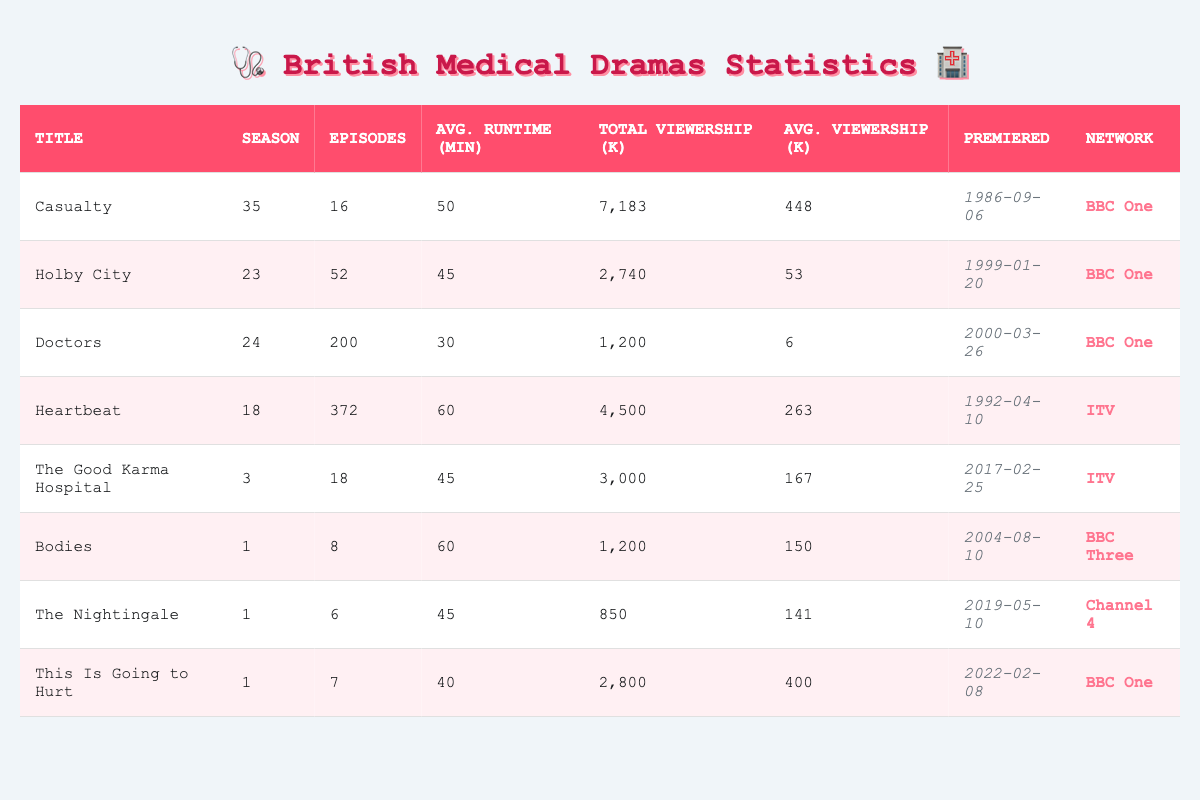What is the average runtime of "Doctors"? The average runtime for "Doctors" as listed in the table is 30 minutes.
Answer: 30 minutes Which show has the highest total viewership? "Casualty" has the highest total viewership with 7,183 thousands (or 7.183 million) viewers.
Answer: Casualty How many seasons does "Heartbeat" have? "Heartbeat" is reported to have 18 seasons.
Answer: 18 seasons What is the average viewership of "The Good Karma Hospital"? The average viewership for "The Good Karma Hospital" is 167 thousands (or 167,000) viewers.
Answer: 167 thousands Which show aired first, "Holby City" or "Doctors"? "Holby City" premiered on January 20, 1999, whereas "Doctors" premiered on March 26, 2000. Therefore, "Holby City" aired first.
Answer: Holby City How many episodes does "Bodies" have compared to "This Is Going to Hurt"? "Bodies" has 8 episodes while "This Is Going to Hurt" has 7 episodes, so "Bodies" has 1 more episode than "This Is Going to Hurt."
Answer: 1 more episode What is the total number of episodes for shows aired on BBC One? The total number of episodes for shows on BBC One (Casualty has 16, Holby City has 52, Doctors has 200, and This Is Going to Hurt has 7) is calculated as 16 + 52 + 200 + 7 = 275 episodes.
Answer: 275 episodes Is the average runtime of "Casualty" longer than that of "The Nightingale"? The average runtime of "Casualty" is 50 minutes while "The Nightingale" is 45 minutes. Since 50 is greater than 45, the statement is true.
Answer: Yes Which network has the most shows listed in the table? The table lists only British medical dramas from BBC One (4 shows), ITV (2 shows), BBC Three (1 show), and Channel 4 (1 show). BBC One has the most shows.
Answer: BBC One What is the average episode runtime for all shows combined? The average runtime for all shows is calculated by summing the runtimes (50 + 45 + 30 + 60 + 45 + 60 + 45 + 40) and dividing by the number of shows (8), which equals 45.625 minutes, so rounding gives approximately 46 minutes.
Answer: 46 minutes Which show has the lowest average viewership per episode? "Doctors" has the lowest average viewership per episode at 6 thousands (or 6,000) viewers.
Answer: Doctors 